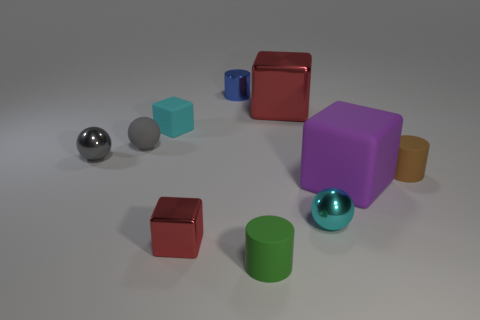There is another metal block that is the same color as the tiny shiny block; what size is it? The metal block that shares the same shiny silver color as the smaller one is considerably larger in size, which suggests that although they share material characteristics, they differ significantly in scale. 